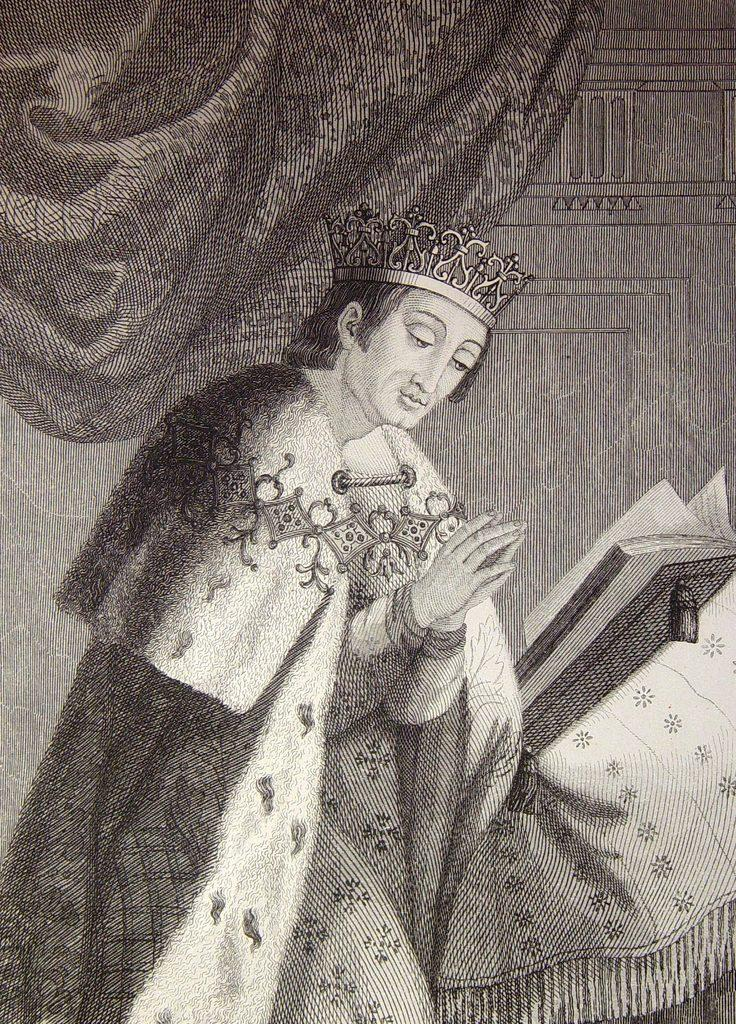What is featured on the poster in the image? The poster contains a person and a book. What can be seen in the background of the image? There is a curtain and a wall in the background of the image. What is the rate of the cracker in the image? There is no cracker present in the image, so it is not possible to determine a rate. 